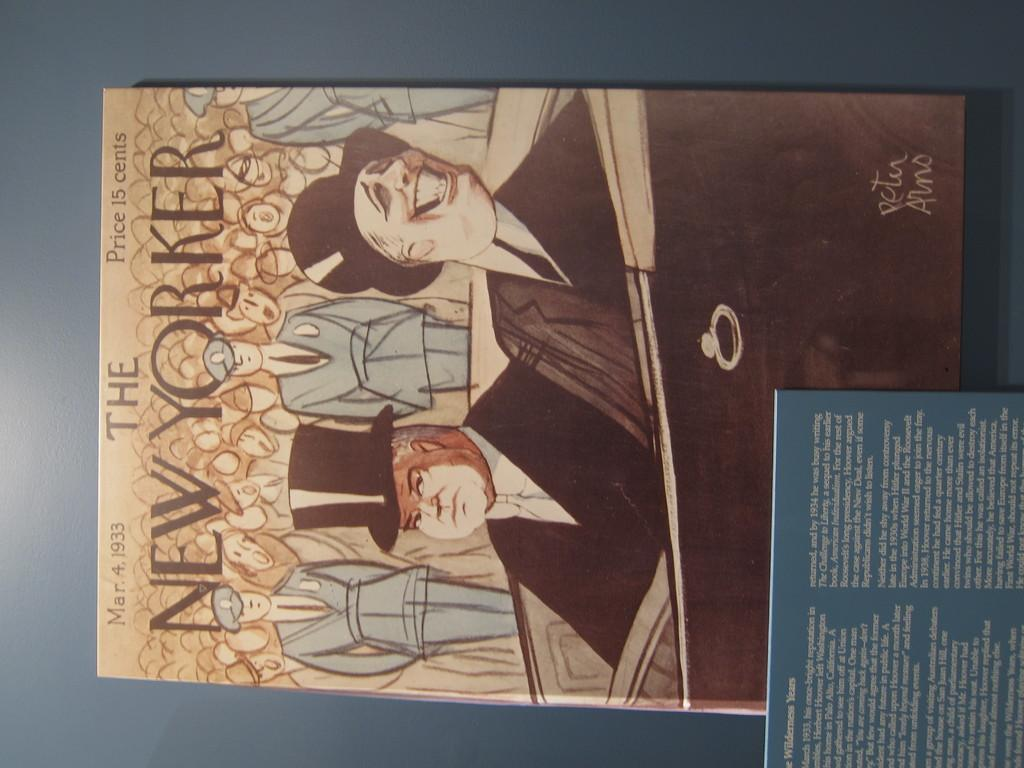What is the main subject of the image? The main subject of the image is a book with depictions of persons and text. Are there any other books visible in the image? Yes, there is another book in the bottom right of the image. What type of grass is growing in the image? There is no grass present in the image; it features two books. 